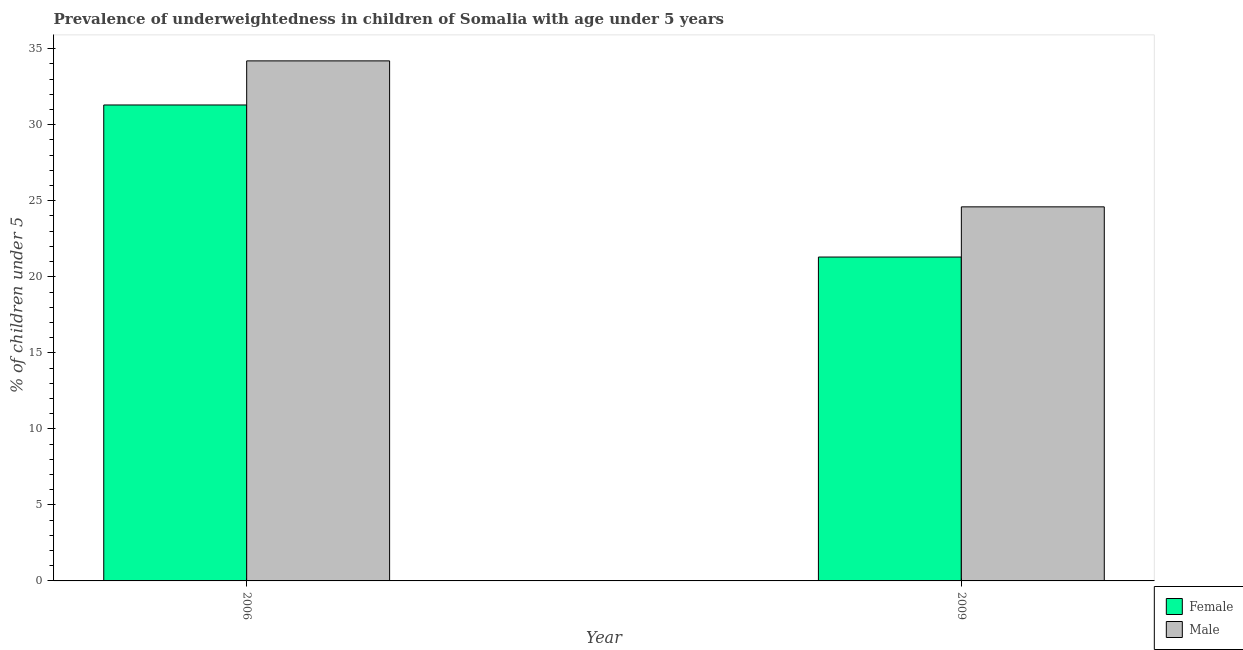How many different coloured bars are there?
Offer a very short reply. 2. How many groups of bars are there?
Ensure brevity in your answer.  2. Are the number of bars per tick equal to the number of legend labels?
Your answer should be compact. Yes. Are the number of bars on each tick of the X-axis equal?
Keep it short and to the point. Yes. How many bars are there on the 2nd tick from the left?
Your answer should be very brief. 2. What is the percentage of underweighted male children in 2006?
Provide a short and direct response. 34.2. Across all years, what is the maximum percentage of underweighted male children?
Your answer should be very brief. 34.2. Across all years, what is the minimum percentage of underweighted male children?
Ensure brevity in your answer.  24.6. In which year was the percentage of underweighted male children minimum?
Your answer should be compact. 2009. What is the total percentage of underweighted male children in the graph?
Provide a short and direct response. 58.8. What is the difference between the percentage of underweighted male children in 2006 and that in 2009?
Offer a very short reply. 9.6. What is the difference between the percentage of underweighted female children in 2009 and the percentage of underweighted male children in 2006?
Ensure brevity in your answer.  -10. What is the average percentage of underweighted male children per year?
Keep it short and to the point. 29.4. In the year 2006, what is the difference between the percentage of underweighted male children and percentage of underweighted female children?
Provide a short and direct response. 0. In how many years, is the percentage of underweighted male children greater than 24 %?
Provide a short and direct response. 2. What is the ratio of the percentage of underweighted female children in 2006 to that in 2009?
Give a very brief answer. 1.47. In how many years, is the percentage of underweighted male children greater than the average percentage of underweighted male children taken over all years?
Provide a succinct answer. 1. What does the 2nd bar from the left in 2009 represents?
Make the answer very short. Male. How many bars are there?
Your answer should be compact. 4. Are all the bars in the graph horizontal?
Make the answer very short. No. How many years are there in the graph?
Offer a terse response. 2. Does the graph contain grids?
Your response must be concise. No. Where does the legend appear in the graph?
Ensure brevity in your answer.  Bottom right. How many legend labels are there?
Provide a succinct answer. 2. How are the legend labels stacked?
Your answer should be very brief. Vertical. What is the title of the graph?
Offer a very short reply. Prevalence of underweightedness in children of Somalia with age under 5 years. Does "Non-pregnant women" appear as one of the legend labels in the graph?
Ensure brevity in your answer.  No. What is the label or title of the Y-axis?
Provide a short and direct response.  % of children under 5. What is the  % of children under 5 in Female in 2006?
Offer a very short reply. 31.3. What is the  % of children under 5 in Male in 2006?
Offer a very short reply. 34.2. What is the  % of children under 5 of Female in 2009?
Provide a short and direct response. 21.3. What is the  % of children under 5 in Male in 2009?
Offer a terse response. 24.6. Across all years, what is the maximum  % of children under 5 in Female?
Offer a very short reply. 31.3. Across all years, what is the maximum  % of children under 5 of Male?
Keep it short and to the point. 34.2. Across all years, what is the minimum  % of children under 5 of Female?
Give a very brief answer. 21.3. Across all years, what is the minimum  % of children under 5 in Male?
Keep it short and to the point. 24.6. What is the total  % of children under 5 in Female in the graph?
Your answer should be compact. 52.6. What is the total  % of children under 5 of Male in the graph?
Provide a succinct answer. 58.8. What is the difference between the  % of children under 5 in Female in 2006 and that in 2009?
Keep it short and to the point. 10. What is the difference between the  % of children under 5 in Male in 2006 and that in 2009?
Provide a succinct answer. 9.6. What is the average  % of children under 5 of Female per year?
Offer a terse response. 26.3. What is the average  % of children under 5 in Male per year?
Provide a succinct answer. 29.4. In the year 2009, what is the difference between the  % of children under 5 of Female and  % of children under 5 of Male?
Give a very brief answer. -3.3. What is the ratio of the  % of children under 5 in Female in 2006 to that in 2009?
Offer a very short reply. 1.47. What is the ratio of the  % of children under 5 of Male in 2006 to that in 2009?
Offer a terse response. 1.39. 